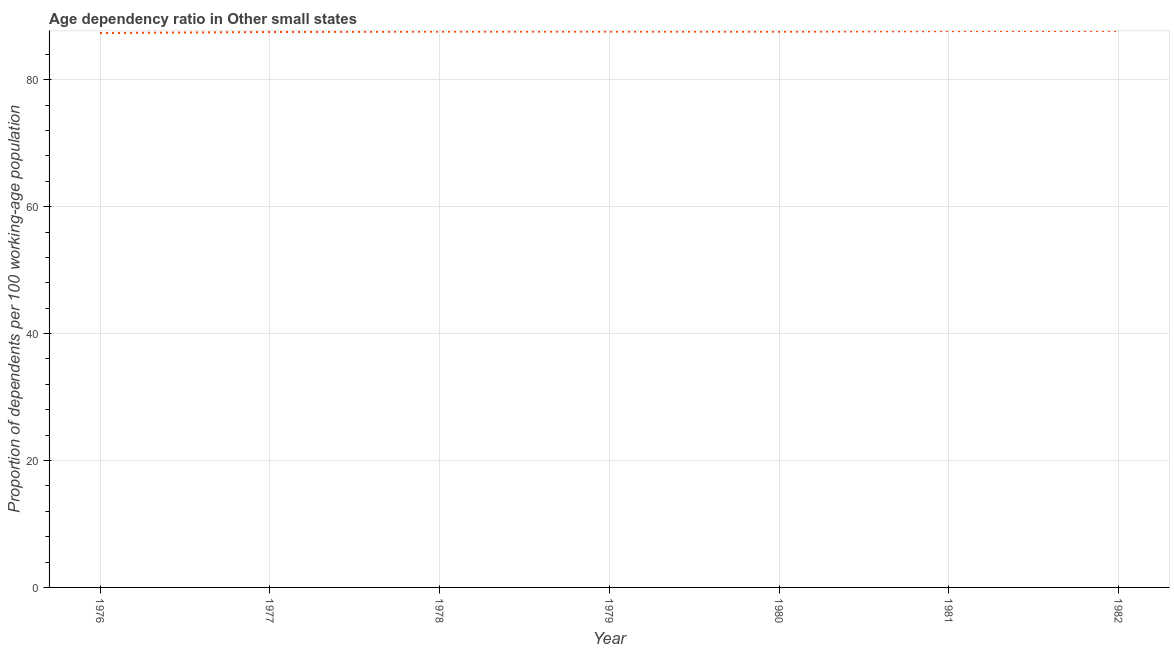What is the age dependency ratio in 1978?
Offer a terse response. 87.58. Across all years, what is the maximum age dependency ratio?
Offer a terse response. 87.7. Across all years, what is the minimum age dependency ratio?
Your answer should be compact. 87.36. In which year was the age dependency ratio maximum?
Your answer should be compact. 1982. In which year was the age dependency ratio minimum?
Ensure brevity in your answer.  1976. What is the sum of the age dependency ratio?
Ensure brevity in your answer.  613.01. What is the difference between the age dependency ratio in 1976 and 1979?
Give a very brief answer. -0.23. What is the average age dependency ratio per year?
Provide a short and direct response. 87.57. What is the median age dependency ratio?
Provide a succinct answer. 87.58. In how many years, is the age dependency ratio greater than 12 ?
Your response must be concise. 7. What is the ratio of the age dependency ratio in 1979 to that in 1982?
Provide a succinct answer. 1. Is the age dependency ratio in 1978 less than that in 1982?
Your answer should be compact. Yes. Is the difference between the age dependency ratio in 1978 and 1980 greater than the difference between any two years?
Ensure brevity in your answer.  No. What is the difference between the highest and the second highest age dependency ratio?
Give a very brief answer. 0.03. Is the sum of the age dependency ratio in 1976 and 1977 greater than the maximum age dependency ratio across all years?
Provide a short and direct response. Yes. What is the difference between the highest and the lowest age dependency ratio?
Offer a very short reply. 0.34. Does the age dependency ratio monotonically increase over the years?
Provide a succinct answer. No. How many years are there in the graph?
Give a very brief answer. 7. What is the difference between two consecutive major ticks on the Y-axis?
Give a very brief answer. 20. Are the values on the major ticks of Y-axis written in scientific E-notation?
Your answer should be very brief. No. Does the graph contain any zero values?
Your answer should be compact. No. Does the graph contain grids?
Your response must be concise. Yes. What is the title of the graph?
Make the answer very short. Age dependency ratio in Other small states. What is the label or title of the X-axis?
Provide a short and direct response. Year. What is the label or title of the Y-axis?
Provide a short and direct response. Proportion of dependents per 100 working-age population. What is the Proportion of dependents per 100 working-age population of 1976?
Provide a short and direct response. 87.36. What is the Proportion of dependents per 100 working-age population of 1977?
Offer a terse response. 87.53. What is the Proportion of dependents per 100 working-age population in 1978?
Offer a very short reply. 87.58. What is the Proportion of dependents per 100 working-age population in 1979?
Your response must be concise. 87.59. What is the Proportion of dependents per 100 working-age population in 1980?
Provide a short and direct response. 87.58. What is the Proportion of dependents per 100 working-age population in 1981?
Give a very brief answer. 87.67. What is the Proportion of dependents per 100 working-age population of 1982?
Give a very brief answer. 87.7. What is the difference between the Proportion of dependents per 100 working-age population in 1976 and 1977?
Ensure brevity in your answer.  -0.17. What is the difference between the Proportion of dependents per 100 working-age population in 1976 and 1978?
Make the answer very short. -0.22. What is the difference between the Proportion of dependents per 100 working-age population in 1976 and 1979?
Your response must be concise. -0.23. What is the difference between the Proportion of dependents per 100 working-age population in 1976 and 1980?
Offer a terse response. -0.21. What is the difference between the Proportion of dependents per 100 working-age population in 1976 and 1981?
Your response must be concise. -0.31. What is the difference between the Proportion of dependents per 100 working-age population in 1976 and 1982?
Give a very brief answer. -0.34. What is the difference between the Proportion of dependents per 100 working-age population in 1977 and 1978?
Your answer should be very brief. -0.06. What is the difference between the Proportion of dependents per 100 working-age population in 1977 and 1979?
Ensure brevity in your answer.  -0.06. What is the difference between the Proportion of dependents per 100 working-age population in 1977 and 1980?
Make the answer very short. -0.05. What is the difference between the Proportion of dependents per 100 working-age population in 1977 and 1981?
Keep it short and to the point. -0.14. What is the difference between the Proportion of dependents per 100 working-age population in 1977 and 1982?
Provide a succinct answer. -0.17. What is the difference between the Proportion of dependents per 100 working-age population in 1978 and 1979?
Your answer should be very brief. -0.01. What is the difference between the Proportion of dependents per 100 working-age population in 1978 and 1980?
Your answer should be very brief. 0.01. What is the difference between the Proportion of dependents per 100 working-age population in 1978 and 1981?
Your answer should be very brief. -0.08. What is the difference between the Proportion of dependents per 100 working-age population in 1978 and 1982?
Offer a terse response. -0.11. What is the difference between the Proportion of dependents per 100 working-age population in 1979 and 1980?
Give a very brief answer. 0.02. What is the difference between the Proportion of dependents per 100 working-age population in 1979 and 1981?
Your answer should be compact. -0.08. What is the difference between the Proportion of dependents per 100 working-age population in 1979 and 1982?
Your response must be concise. -0.11. What is the difference between the Proportion of dependents per 100 working-age population in 1980 and 1981?
Keep it short and to the point. -0.09. What is the difference between the Proportion of dependents per 100 working-age population in 1980 and 1982?
Your response must be concise. -0.12. What is the difference between the Proportion of dependents per 100 working-age population in 1981 and 1982?
Make the answer very short. -0.03. What is the ratio of the Proportion of dependents per 100 working-age population in 1976 to that in 1978?
Make the answer very short. 1. What is the ratio of the Proportion of dependents per 100 working-age population in 1976 to that in 1979?
Provide a short and direct response. 1. What is the ratio of the Proportion of dependents per 100 working-age population in 1977 to that in 1979?
Give a very brief answer. 1. What is the ratio of the Proportion of dependents per 100 working-age population in 1977 to that in 1981?
Give a very brief answer. 1. What is the ratio of the Proportion of dependents per 100 working-age population in 1978 to that in 1980?
Offer a terse response. 1. What is the ratio of the Proportion of dependents per 100 working-age population in 1978 to that in 1981?
Offer a terse response. 1. What is the ratio of the Proportion of dependents per 100 working-age population in 1978 to that in 1982?
Provide a succinct answer. 1. What is the ratio of the Proportion of dependents per 100 working-age population in 1979 to that in 1980?
Provide a succinct answer. 1. What is the ratio of the Proportion of dependents per 100 working-age population in 1979 to that in 1982?
Give a very brief answer. 1. What is the ratio of the Proportion of dependents per 100 working-age population in 1980 to that in 1981?
Make the answer very short. 1. What is the ratio of the Proportion of dependents per 100 working-age population in 1980 to that in 1982?
Your response must be concise. 1. 